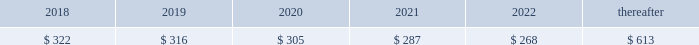92 | 2017 form 10-k finite-lived intangible assets are amortized over their estimated useful lives and tested for impairment if events or changes in circumstances indicate that the asset may be impaired .
In 2016 , gross customer relationship intangibles of $ 96 million and related accumulated amortization of $ 27 million as well as gross intellectual property intangibles of $ 111 million and related accumulated amortization of $ 48 million from the resource industries segment were impaired .
The fair value of these intangibles was determined to be insignificant based on an income approach using expected cash flows .
The fair value determination is categorized as level 3 in the fair value hierarchy due to its use of internal projections and unobservable measurement inputs .
The total impairment of $ 132 million was a result of restructuring activities and is included in other operating ( income ) expense in statement 1 .
See note 25 for information on restructuring costs .
Amortization expense related to intangible assets was $ 323 million , $ 326 million and $ 337 million for 2017 , 2016 and 2015 , respectively .
As of december 31 , 2017 , amortization expense related to intangible assets is expected to be : ( millions of dollars ) .
Goodwill there were no goodwill impairments during 2017 or 2015 .
Our annual impairment tests completed in the fourth quarter of 2016 indicated the fair value of each reporting unit was substantially above its respective carrying value , including goodwill , with the exception of our surface mining & technology reporting unit .
The surface mining & technology reporting unit , which primarily serves the mining industry , is a part of our resource industries segment .
The goodwill assigned to this reporting unit is largely from our acquisition of bucyrus international , inc .
In 2011 .
Its product portfolio includes large mining trucks , electric rope shovels , draglines , hydraulic shovels and related parts .
In addition to equipment , surface mining & technology also develops and sells technology products and services to provide customer fleet management , equipment management analytics and autonomous machine capabilities .
The annual impairment test completed in the fourth quarter of 2016 indicated that the fair value of surface mining & technology was below its carrying value requiring the second step of the goodwill impairment test process .
The fair value of surface mining & technology was determined primarily using an income approach based on a discounted ten year cash flow .
We assigned the fair value to surface mining & technology 2019s assets and liabilities using various valuation techniques that required assumptions about royalty rates , dealer attrition , technological obsolescence and discount rates .
The resulting implied fair value of goodwill was below the carrying value .
Accordingly , we recognized a goodwill impairment charge of $ 595 million , which resulted in goodwill of $ 629 million remaining for surface mining & technology as of october 1 , 2016 .
The fair value determination is categorized as level 3 in the fair value hierarchy due to its use of internal projections and unobservable measurement inputs .
There was a $ 17 million tax benefit associated with this impairment charge. .
What was pre impairment goodwill in millions for surface mining & technology as of october 1 , 2016? 
Computations: (595 + 629)
Answer: 1224.0. 